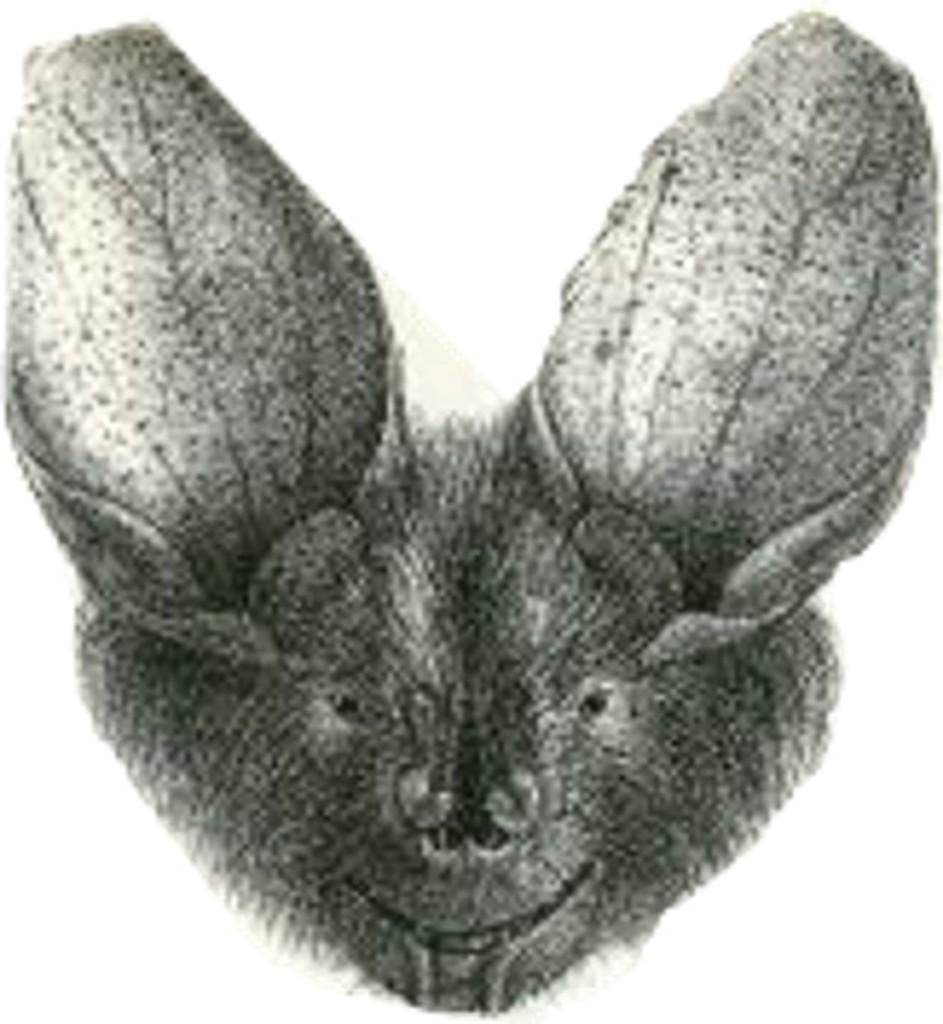What is the color scheme of the image? The image is black and white. What type of subject can be seen in the image? There is an animal in the image. What grade does the animal receive for its performance in the town? There is no indication of a town, performance, or grade in the image, as it only features a black and white image of an animal. 